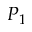Convert formula to latex. <formula><loc_0><loc_0><loc_500><loc_500>P _ { 1 }</formula> 